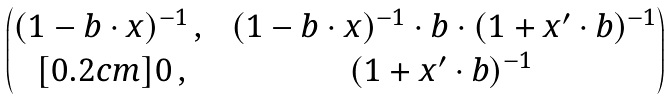<formula> <loc_0><loc_0><loc_500><loc_500>\begin{pmatrix} ( 1 - b \cdot x ) ^ { - 1 } \, , \, & \, ( 1 - b \cdot x ) ^ { - 1 } \cdot b \cdot ( 1 + x ^ { \prime } \cdot b ) ^ { - 1 } \\ [ 0 . 2 c m ] 0 \, , & ( 1 + x ^ { \prime } \cdot b ) ^ { - 1 } \end{pmatrix}</formula> 